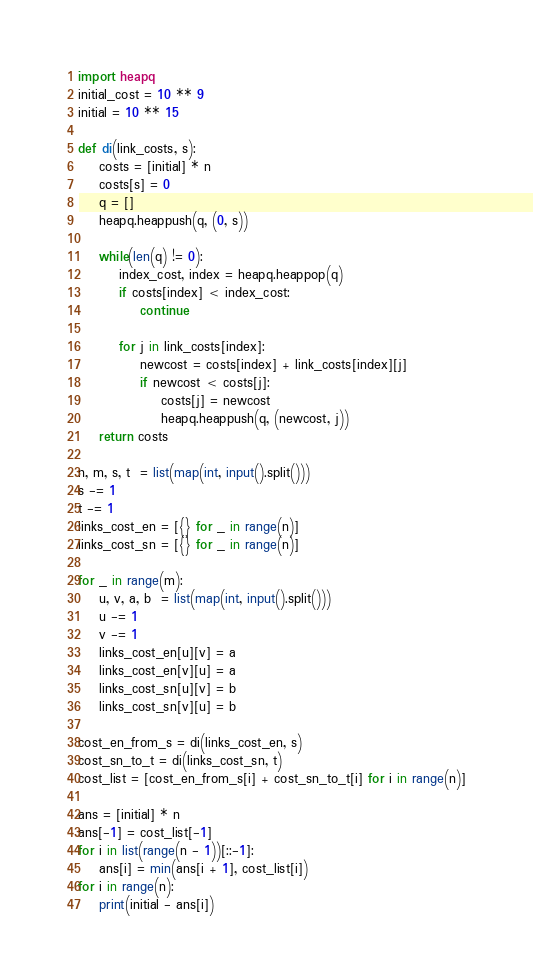Convert code to text. <code><loc_0><loc_0><loc_500><loc_500><_Python_>import heapq
initial_cost = 10 ** 9
initial = 10 ** 15

def di(link_costs, s):
    costs = [initial] * n
    costs[s] = 0
    q = []
    heapq.heappush(q, (0, s))
    
    while(len(q) != 0):
        index_cost, index = heapq.heappop(q)
        if costs[index] < index_cost:
            continue

        for j in link_costs[index]:
            newcost = costs[index] + link_costs[index][j]
            if newcost < costs[j]:
                costs[j] = newcost
                heapq.heappush(q, (newcost, j))
    return costs
    
n, m, s, t  = list(map(int, input().split()))
s -= 1
t -= 1
links_cost_en = [{} for _ in range(n)]
links_cost_sn = [{} for _ in range(n)]

for _ in range(m):
    u, v, a, b  = list(map(int, input().split()))
    u -= 1
    v -= 1
    links_cost_en[u][v] = a
    links_cost_en[v][u] = a
    links_cost_sn[u][v] = b
    links_cost_sn[v][u] = b

cost_en_from_s = di(links_cost_en, s)
cost_sn_to_t = di(links_cost_sn, t)
cost_list = [cost_en_from_s[i] + cost_sn_to_t[i] for i in range(n)]

ans = [initial] * n
ans[-1] = cost_list[-1]
for i in list(range(n - 1))[::-1]:
    ans[i] = min(ans[i + 1], cost_list[i])
for i in range(n):
    print(initial - ans[i])</code> 